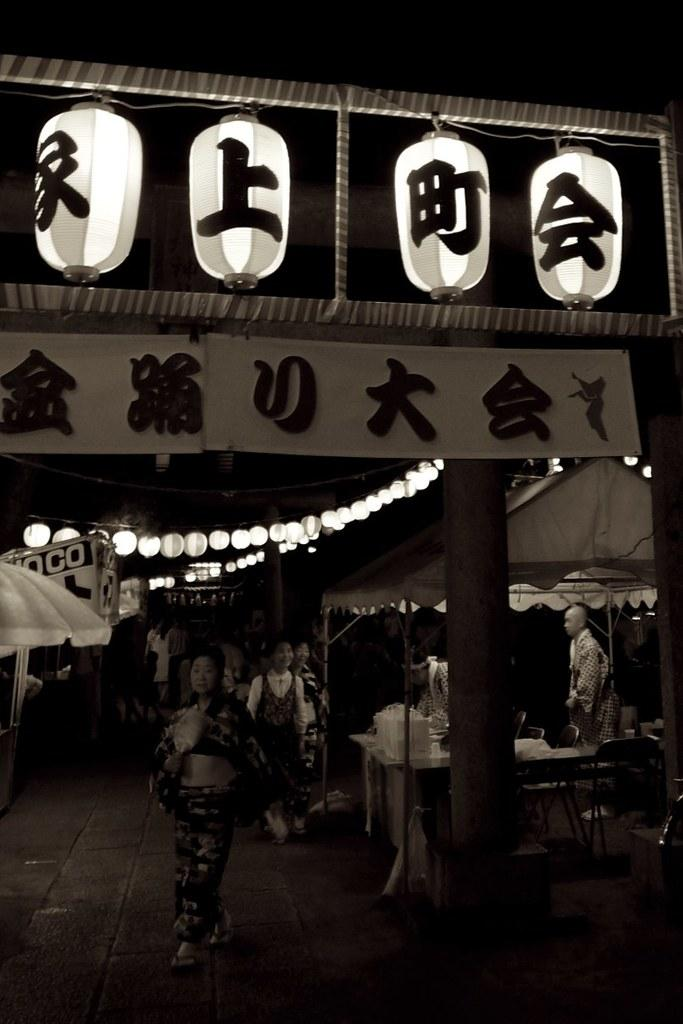What is the color scheme of the image? The image is black and white. What type of objects can be seen in the image? There are boards, lights, people, tents, objects on a table, chairs, and a floor visible in the image. Can you describe the setting of the image? The image appears to depict an outdoor or tented area, with people gathered around a table and chairs. What is the floor made of in the image? The floor visible at the bottom of the image is not specified, but it could be made of various materials such as wood, concrete, or grass. What type of building is depicted in the image? There is no building present in the image; it features tents and other outdoor objects. Can you tell me how many divisions are visible in the image? The concept of divisions is not applicable to this image, as it does not depict any structures or areas that could be divided. Is there a scarf visible on any of the people in the image? The presence of a scarf is not mentioned in the provided facts, so it cannot be determined from the image. 